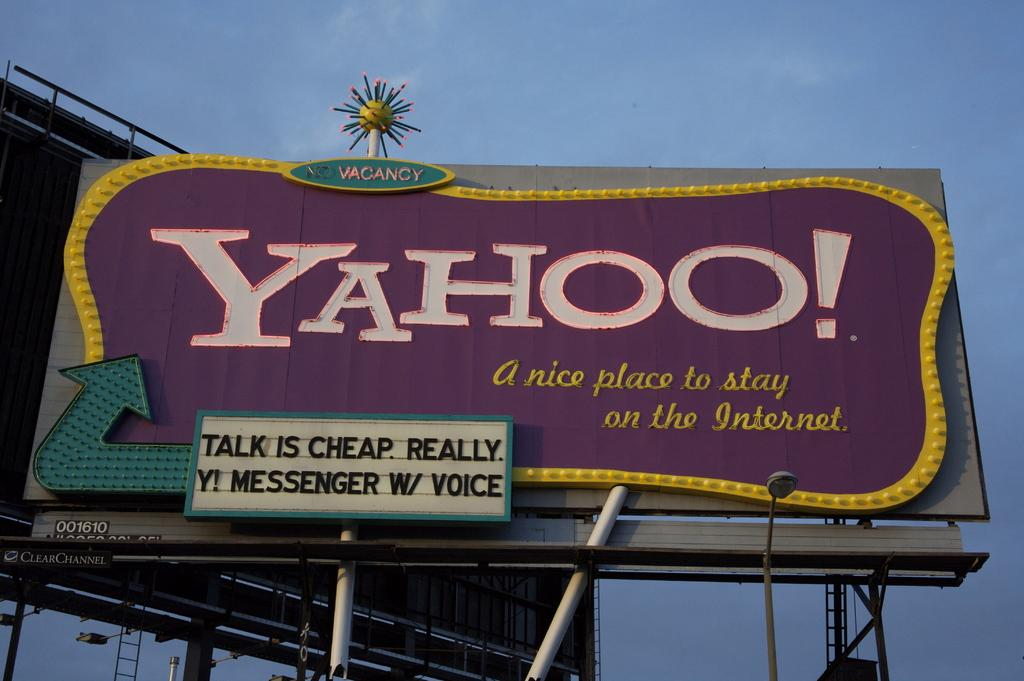<image>
Describe the image concisely. A purple and yellow billboard sign for Yahoo. 